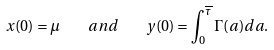<formula> <loc_0><loc_0><loc_500><loc_500>x ( 0 ) = \mu \quad a n d \quad y ( 0 ) = \int _ { 0 } ^ { \overline { \tau } } \Gamma ( a ) d a .</formula> 